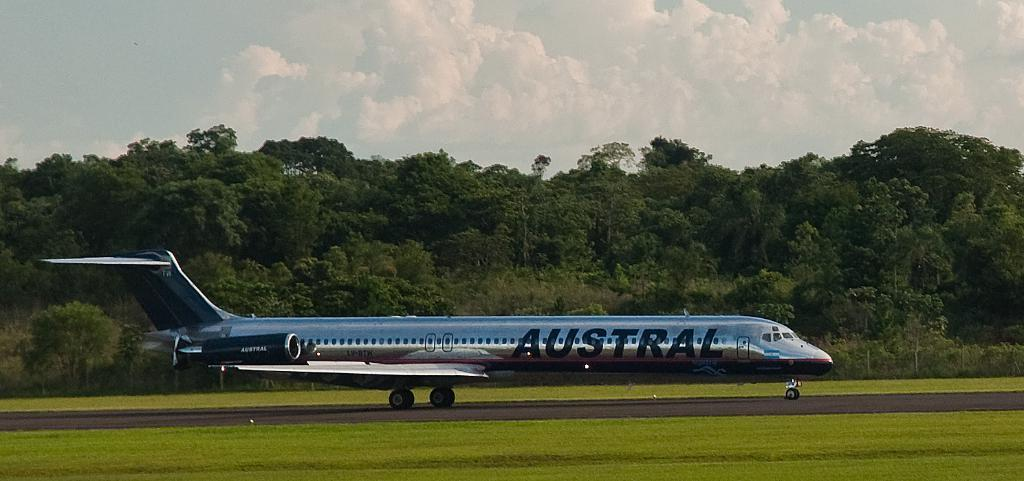Provide a one-sentence caption for the provided image. Austral is on the side of a silver plane. 